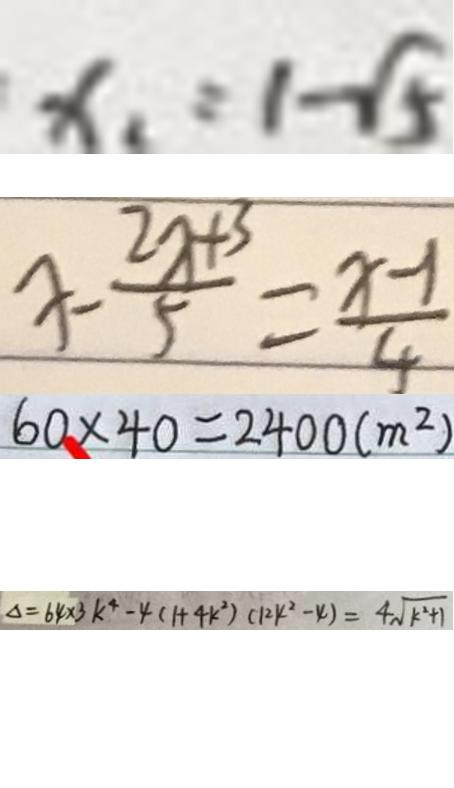<formula> <loc_0><loc_0><loc_500><loc_500>x _ { 1 } = 1 - \sqrt { 5 } 
 x - \frac { 2 x + 3 } { 5 } = \frac { x - 1 } { 4 } 
 6 0 \times 4 0 = 2 4 0 0 ( m ^ { 2 } ) 
 \Delta = 6 4 \times 3 k ^ { 4 } - 4 ( 1 + 4 k ^ { 2 } ) ( 1 2 k ^ { 2 } - 4 ) = 4 \sqrt { k ^ { 2 } + 1 }</formula> 